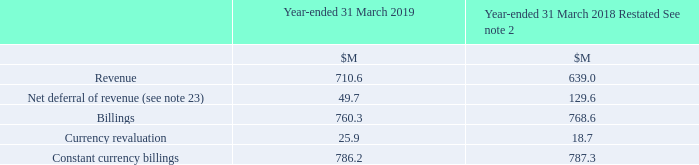Billings
Billings represent the value of products and services invoiced to customers after receiving a purchase order from the customer and delivering products and services to them, or for which there is no right to a refund. Billings do not equate to statutory revenue.
What do Billings represent? The value of products and services invoiced to customers after receiving a purchase order from the customer and delivering products and services to them, or for which there is no right to a refund. billings do not equate to statutory revenue. What was the amount of Billings in 2019?
Answer scale should be: million. 760.3. What were the components in the table used to calculate Billings? Revenue, net deferral of revenue. In which year was the amount of Billings larger? 768.6>760.3
Answer: 2018. What was the change in Revenue in 2019 from 2018?
Answer scale should be: million. 710.6-639.0
Answer: 71.6. What was the percentage change in Revenue in 2019 from 2018?
Answer scale should be: percent. (710.6-639.0)/639.0
Answer: 11.21. 